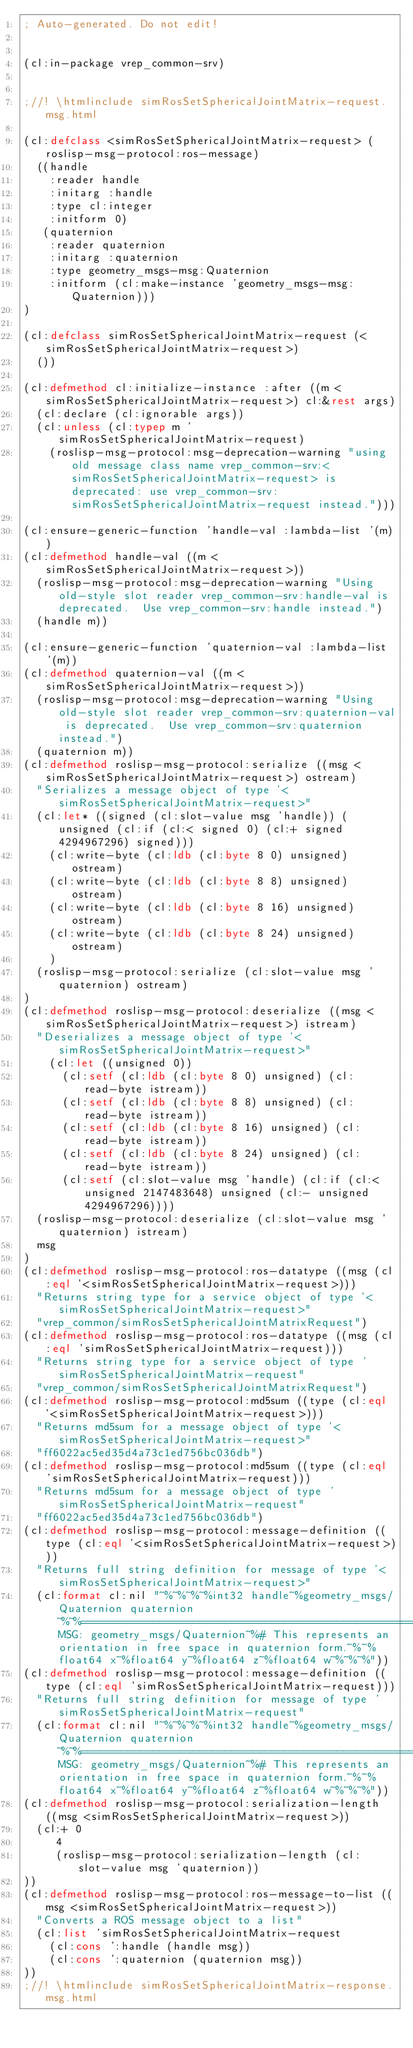Convert code to text. <code><loc_0><loc_0><loc_500><loc_500><_Lisp_>; Auto-generated. Do not edit!


(cl:in-package vrep_common-srv)


;//! \htmlinclude simRosSetSphericalJointMatrix-request.msg.html

(cl:defclass <simRosSetSphericalJointMatrix-request> (roslisp-msg-protocol:ros-message)
  ((handle
    :reader handle
    :initarg :handle
    :type cl:integer
    :initform 0)
   (quaternion
    :reader quaternion
    :initarg :quaternion
    :type geometry_msgs-msg:Quaternion
    :initform (cl:make-instance 'geometry_msgs-msg:Quaternion)))
)

(cl:defclass simRosSetSphericalJointMatrix-request (<simRosSetSphericalJointMatrix-request>)
  ())

(cl:defmethod cl:initialize-instance :after ((m <simRosSetSphericalJointMatrix-request>) cl:&rest args)
  (cl:declare (cl:ignorable args))
  (cl:unless (cl:typep m 'simRosSetSphericalJointMatrix-request)
    (roslisp-msg-protocol:msg-deprecation-warning "using old message class name vrep_common-srv:<simRosSetSphericalJointMatrix-request> is deprecated: use vrep_common-srv:simRosSetSphericalJointMatrix-request instead.")))

(cl:ensure-generic-function 'handle-val :lambda-list '(m))
(cl:defmethod handle-val ((m <simRosSetSphericalJointMatrix-request>))
  (roslisp-msg-protocol:msg-deprecation-warning "Using old-style slot reader vrep_common-srv:handle-val is deprecated.  Use vrep_common-srv:handle instead.")
  (handle m))

(cl:ensure-generic-function 'quaternion-val :lambda-list '(m))
(cl:defmethod quaternion-val ((m <simRosSetSphericalJointMatrix-request>))
  (roslisp-msg-protocol:msg-deprecation-warning "Using old-style slot reader vrep_common-srv:quaternion-val is deprecated.  Use vrep_common-srv:quaternion instead.")
  (quaternion m))
(cl:defmethod roslisp-msg-protocol:serialize ((msg <simRosSetSphericalJointMatrix-request>) ostream)
  "Serializes a message object of type '<simRosSetSphericalJointMatrix-request>"
  (cl:let* ((signed (cl:slot-value msg 'handle)) (unsigned (cl:if (cl:< signed 0) (cl:+ signed 4294967296) signed)))
    (cl:write-byte (cl:ldb (cl:byte 8 0) unsigned) ostream)
    (cl:write-byte (cl:ldb (cl:byte 8 8) unsigned) ostream)
    (cl:write-byte (cl:ldb (cl:byte 8 16) unsigned) ostream)
    (cl:write-byte (cl:ldb (cl:byte 8 24) unsigned) ostream)
    )
  (roslisp-msg-protocol:serialize (cl:slot-value msg 'quaternion) ostream)
)
(cl:defmethod roslisp-msg-protocol:deserialize ((msg <simRosSetSphericalJointMatrix-request>) istream)
  "Deserializes a message object of type '<simRosSetSphericalJointMatrix-request>"
    (cl:let ((unsigned 0))
      (cl:setf (cl:ldb (cl:byte 8 0) unsigned) (cl:read-byte istream))
      (cl:setf (cl:ldb (cl:byte 8 8) unsigned) (cl:read-byte istream))
      (cl:setf (cl:ldb (cl:byte 8 16) unsigned) (cl:read-byte istream))
      (cl:setf (cl:ldb (cl:byte 8 24) unsigned) (cl:read-byte istream))
      (cl:setf (cl:slot-value msg 'handle) (cl:if (cl:< unsigned 2147483648) unsigned (cl:- unsigned 4294967296))))
  (roslisp-msg-protocol:deserialize (cl:slot-value msg 'quaternion) istream)
  msg
)
(cl:defmethod roslisp-msg-protocol:ros-datatype ((msg (cl:eql '<simRosSetSphericalJointMatrix-request>)))
  "Returns string type for a service object of type '<simRosSetSphericalJointMatrix-request>"
  "vrep_common/simRosSetSphericalJointMatrixRequest")
(cl:defmethod roslisp-msg-protocol:ros-datatype ((msg (cl:eql 'simRosSetSphericalJointMatrix-request)))
  "Returns string type for a service object of type 'simRosSetSphericalJointMatrix-request"
  "vrep_common/simRosSetSphericalJointMatrixRequest")
(cl:defmethod roslisp-msg-protocol:md5sum ((type (cl:eql '<simRosSetSphericalJointMatrix-request>)))
  "Returns md5sum for a message object of type '<simRosSetSphericalJointMatrix-request>"
  "ff6022ac5ed35d4a73c1ed756bc036db")
(cl:defmethod roslisp-msg-protocol:md5sum ((type (cl:eql 'simRosSetSphericalJointMatrix-request)))
  "Returns md5sum for a message object of type 'simRosSetSphericalJointMatrix-request"
  "ff6022ac5ed35d4a73c1ed756bc036db")
(cl:defmethod roslisp-msg-protocol:message-definition ((type (cl:eql '<simRosSetSphericalJointMatrix-request>)))
  "Returns full string definition for message of type '<simRosSetSphericalJointMatrix-request>"
  (cl:format cl:nil "~%~%~%~%int32 handle~%geometry_msgs/Quaternion quaternion~%~%================================================================================~%MSG: geometry_msgs/Quaternion~%# This represents an orientation in free space in quaternion form.~%~%float64 x~%float64 y~%float64 z~%float64 w~%~%~%"))
(cl:defmethod roslisp-msg-protocol:message-definition ((type (cl:eql 'simRosSetSphericalJointMatrix-request)))
  "Returns full string definition for message of type 'simRosSetSphericalJointMatrix-request"
  (cl:format cl:nil "~%~%~%~%int32 handle~%geometry_msgs/Quaternion quaternion~%~%================================================================================~%MSG: geometry_msgs/Quaternion~%# This represents an orientation in free space in quaternion form.~%~%float64 x~%float64 y~%float64 z~%float64 w~%~%~%"))
(cl:defmethod roslisp-msg-protocol:serialization-length ((msg <simRosSetSphericalJointMatrix-request>))
  (cl:+ 0
     4
     (roslisp-msg-protocol:serialization-length (cl:slot-value msg 'quaternion))
))
(cl:defmethod roslisp-msg-protocol:ros-message-to-list ((msg <simRosSetSphericalJointMatrix-request>))
  "Converts a ROS message object to a list"
  (cl:list 'simRosSetSphericalJointMatrix-request
    (cl:cons ':handle (handle msg))
    (cl:cons ':quaternion (quaternion msg))
))
;//! \htmlinclude simRosSetSphericalJointMatrix-response.msg.html
</code> 